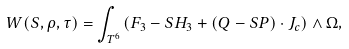<formula> <loc_0><loc_0><loc_500><loc_500>\ W ( S , \rho , \tau ) = \int _ { T ^ { 6 } } \left ( F _ { 3 } - S H _ { 3 } + ( Q - S P ) \cdot J _ { c } \right ) \wedge \Omega ,</formula> 